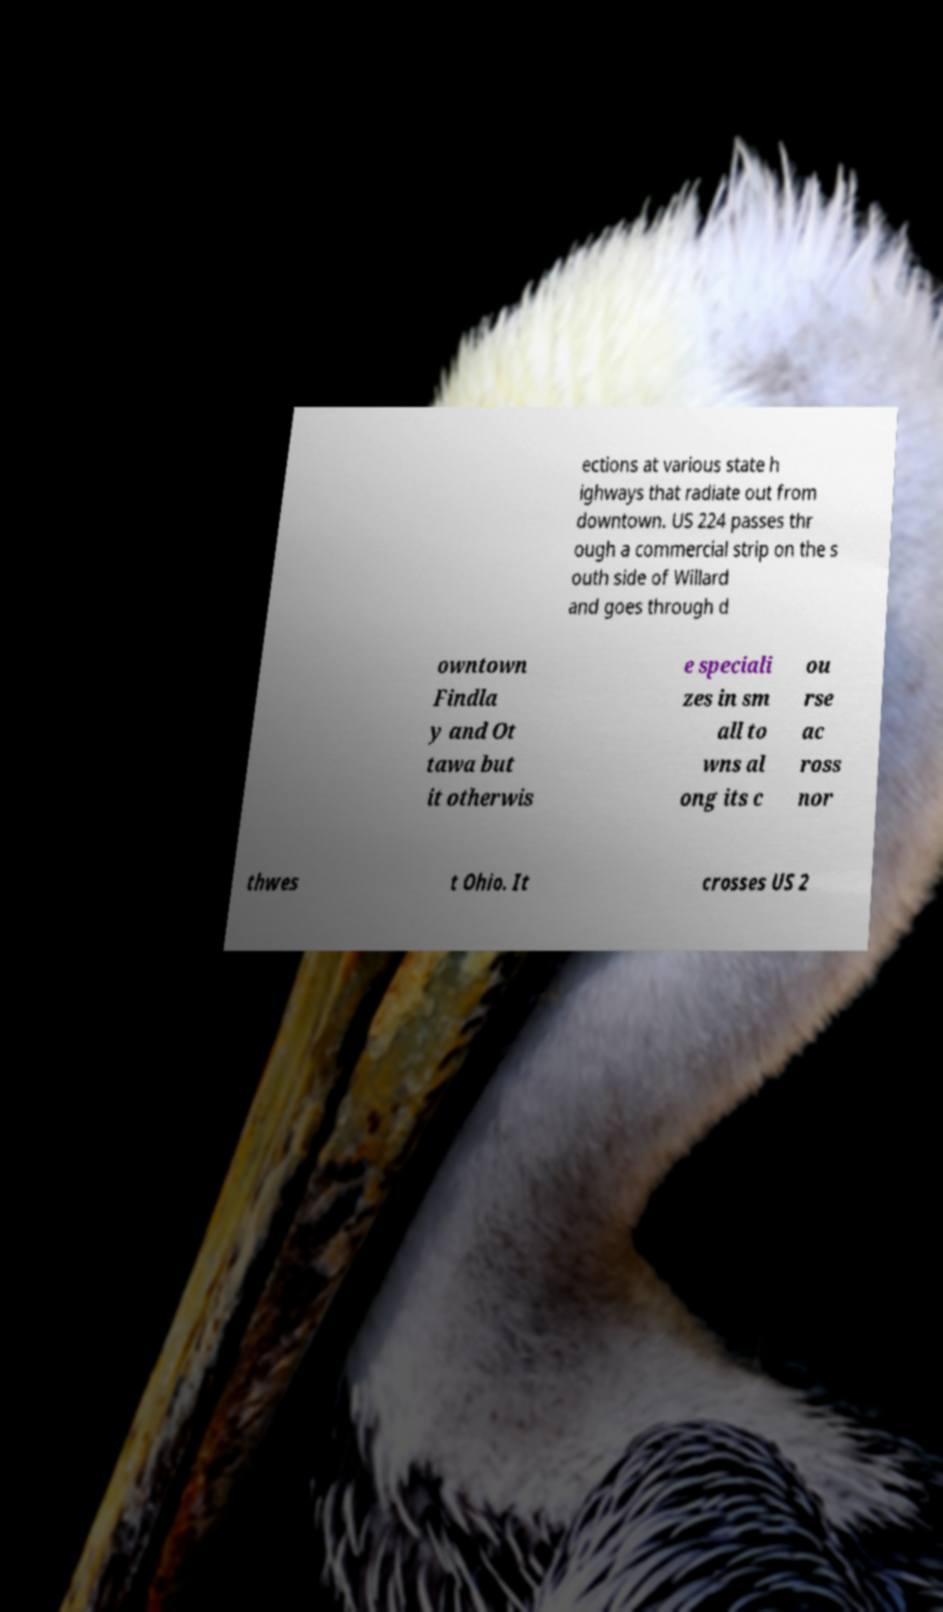Please identify and transcribe the text found in this image. ections at various state h ighways that radiate out from downtown. US 224 passes thr ough a commercial strip on the s outh side of Willard and goes through d owntown Findla y and Ot tawa but it otherwis e speciali zes in sm all to wns al ong its c ou rse ac ross nor thwes t Ohio. It crosses US 2 